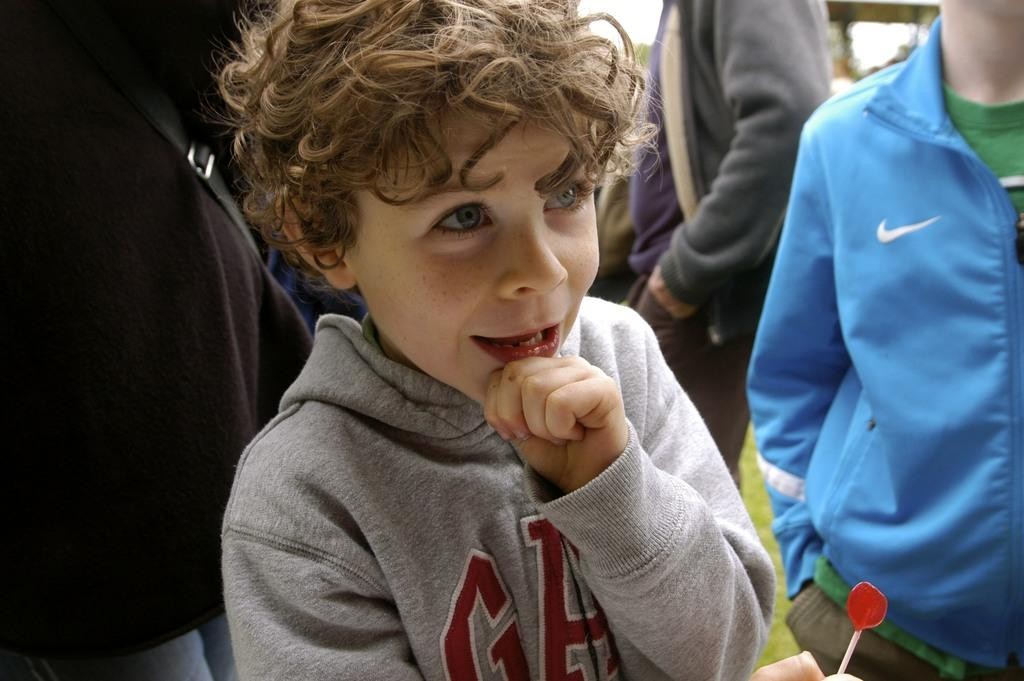Who is the main subject in the image? There is a boy in the image. What is the boy holding in the image? The boy is holding a candy with a stick. Can you describe the setting of the image? There are many people in the background of the image. How much was the payment for the sea in the image? There is no sea or payment mentioned in the image; it features a boy holding a candy with a stick and many people in the background. 